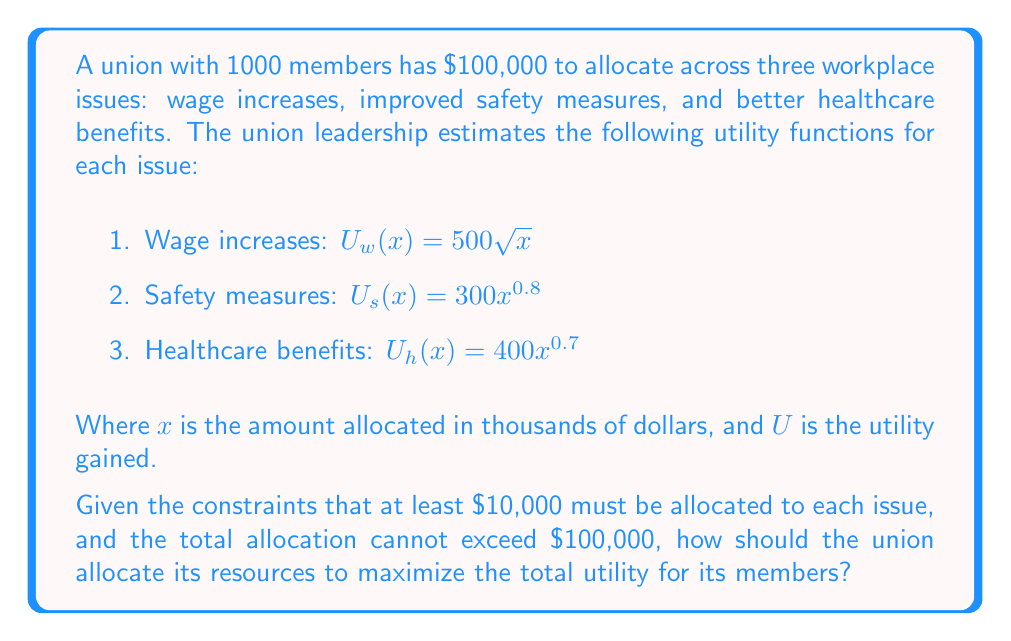Can you answer this question? To solve this problem, we'll use the method of Lagrange multipliers, which is ideal for optimizing constrained problems like this one.

Step 1: Define the objective function
Our goal is to maximize the total utility:
$$U_{total} = U_w(x_1) + U_s(x_2) + U_h(x_3) = 500\sqrt{x_1} + 300x_2^{0.8} + 400x_3^{0.7}$$

Step 2: Define the constraints
1. $x_1 + x_2 + x_3 = 100$ (total budget constraint)
2. $x_1, x_2, x_3 \geq 10$ (minimum allocation constraint)

Step 3: Form the Lagrangian
$$L = 500\sqrt{x_1} + 300x_2^{0.8} + 400x_3^{0.7} - \lambda(x_1 + x_2 + x_3 - 100)$$

Step 4: Take partial derivatives and set them equal to zero
$$\frac{\partial L}{\partial x_1} = \frac{250}{\sqrt{x_1}} - \lambda = 0$$
$$\frac{\partial L}{\partial x_2} = 240x_2^{-0.2} - \lambda = 0$$
$$\frac{\partial L}{\partial x_3} = 280x_3^{-0.3} - \lambda = 0$$
$$\frac{\partial L}{\partial \lambda} = x_1 + x_2 + x_3 - 100 = 0$$

Step 5: Solve the system of equations
From the first three equations:
$$\frac{250}{\sqrt{x_1}} = 240x_2^{-0.2} = 280x_3^{-0.3} = \lambda$$

This implies:
$$x_1 = (\frac{250}{\lambda})^2$$
$$x_2 = (\frac{240}{\lambda})^5$$
$$x_3 = (\frac{280}{\lambda})^{10/3}$$

Substituting into the fourth equation:
$$(\frac{250}{\lambda})^2 + (\frac{240}{\lambda})^5 + (\frac{280}{\lambda})^{10/3} = 100$$

Solving this numerically (as it's not easily solvable analytically), we get:
$$\lambda \approx 35.36$$

Step 6: Calculate the optimal allocations
$$x_1 \approx 50.0$$
$$x_2 \approx 26.7$$
$$x_3 \approx 23.3$$

Step 7: Check constraints
All allocations are above the $10,000 minimum, and they sum to $100,000.

Step 8: Calculate the total utility
$$U_{total} = 500\sqrt{50.0} + 300(26.7)^{0.8} + 400(23.3)^{0.7} \approx 7,105$$
Answer: The optimal allocation to maximize total utility is approximately:
Wage increases: $50,000
Safety measures: $26,700
Healthcare benefits: $23,300

This allocation results in a total utility of about 7,105 units. 